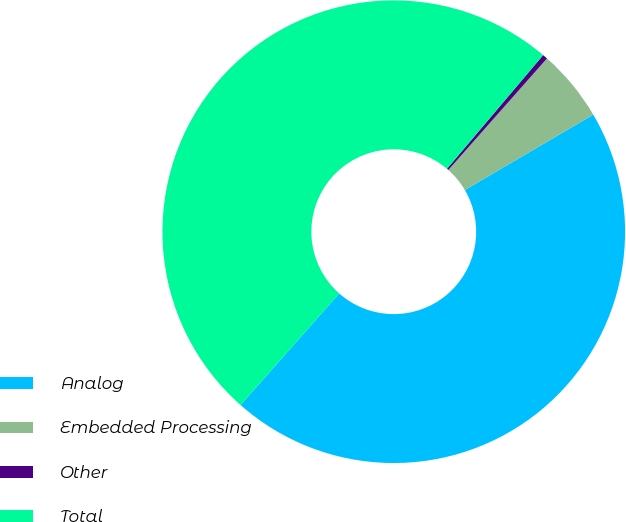<chart> <loc_0><loc_0><loc_500><loc_500><pie_chart><fcel>Analog<fcel>Embedded Processing<fcel>Other<fcel>Total<nl><fcel>44.97%<fcel>5.03%<fcel>0.35%<fcel>49.65%<nl></chart> 